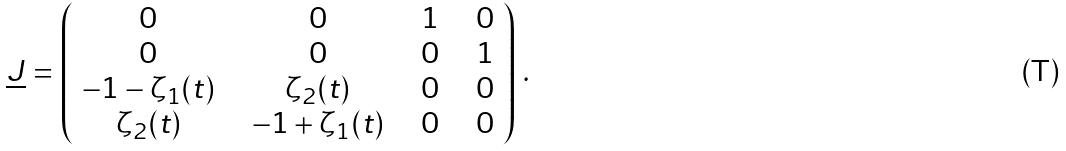<formula> <loc_0><loc_0><loc_500><loc_500>\underline { J } = \left ( \begin{array} { c c c c c c c } 0 & \, & 0 & \, & 1 & \, & 0 \\ 0 & \, & 0 & \, & 0 & \, & 1 \\ - 1 - \zeta _ { 1 } ( t ) & \, & \zeta _ { 2 } ( t ) & \, & 0 & \, & 0 \\ \zeta _ { 2 } ( t ) & \, & - 1 + \zeta _ { 1 } ( t ) & \, & 0 & \, & 0 \end{array} \right ) \, .</formula> 